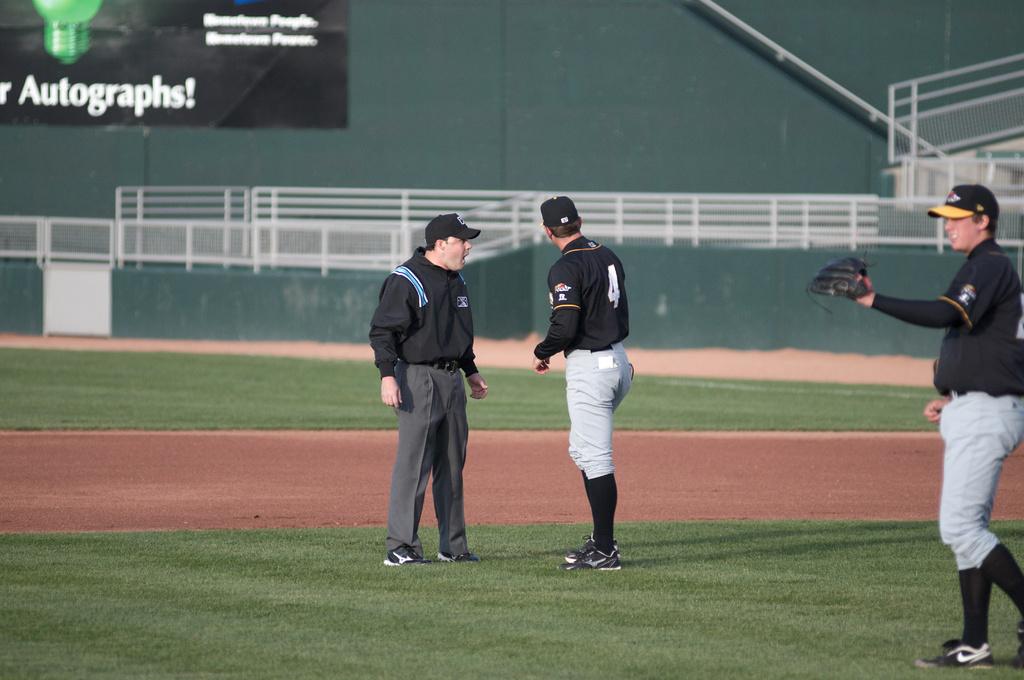What signature type is printed in the background?
Give a very brief answer. Autographs. 